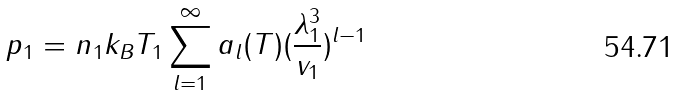<formula> <loc_0><loc_0><loc_500><loc_500>p _ { 1 } = n _ { 1 } k _ { B } T _ { 1 } \sum _ { l = 1 } ^ { \infty } a _ { l } ( T ) ( \frac { \lambda _ { 1 } ^ { 3 } } { v _ { 1 } } ) ^ { l - 1 }</formula> 